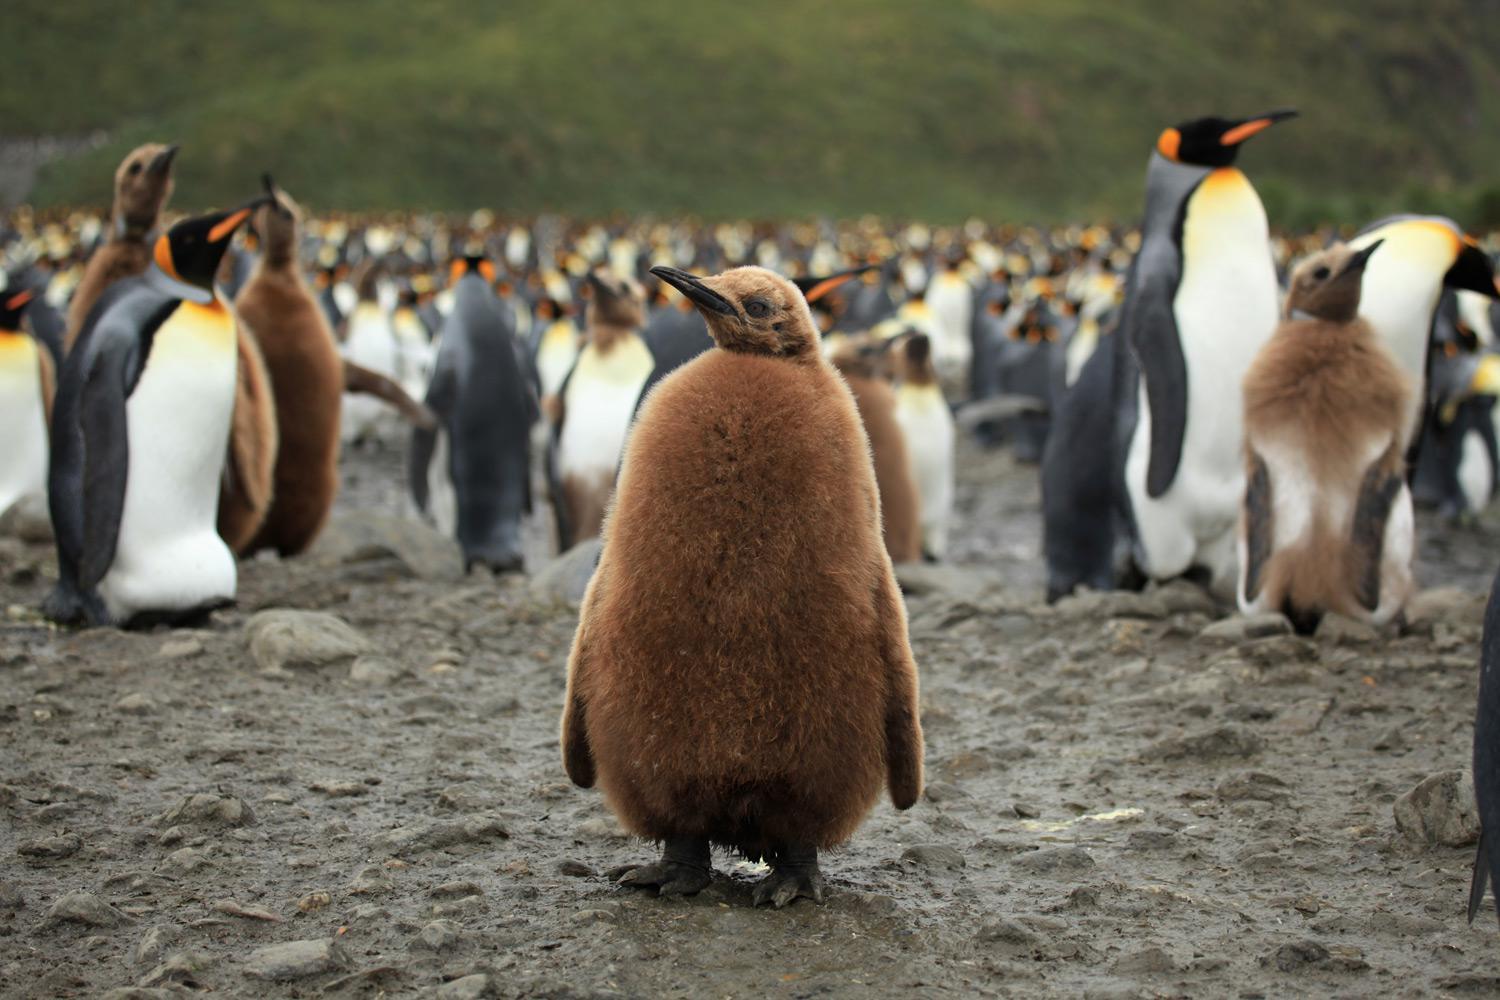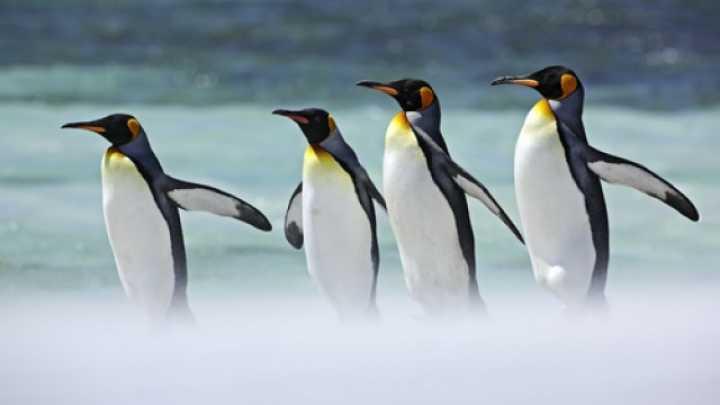The first image is the image on the left, the second image is the image on the right. For the images displayed, is the sentence "A group of four penguins is walking together in the image on the right." factually correct? Answer yes or no. Yes. 